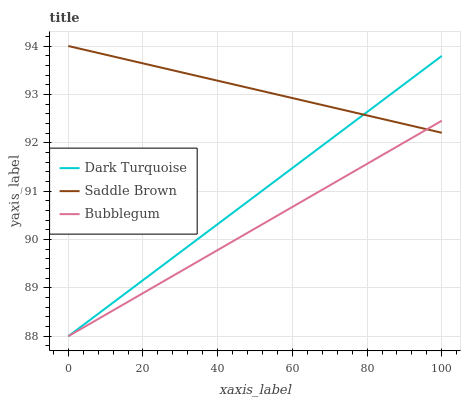Does Bubblegum have the minimum area under the curve?
Answer yes or no. Yes. Does Saddle Brown have the maximum area under the curve?
Answer yes or no. Yes. Does Saddle Brown have the minimum area under the curve?
Answer yes or no. No. Does Bubblegum have the maximum area under the curve?
Answer yes or no. No. Is Dark Turquoise the smoothest?
Answer yes or no. Yes. Is Bubblegum the roughest?
Answer yes or no. Yes. Is Bubblegum the smoothest?
Answer yes or no. No. Is Saddle Brown the roughest?
Answer yes or no. No. Does Dark Turquoise have the lowest value?
Answer yes or no. Yes. Does Saddle Brown have the lowest value?
Answer yes or no. No. Does Saddle Brown have the highest value?
Answer yes or no. Yes. Does Bubblegum have the highest value?
Answer yes or no. No. Does Bubblegum intersect Dark Turquoise?
Answer yes or no. Yes. Is Bubblegum less than Dark Turquoise?
Answer yes or no. No. Is Bubblegum greater than Dark Turquoise?
Answer yes or no. No. 